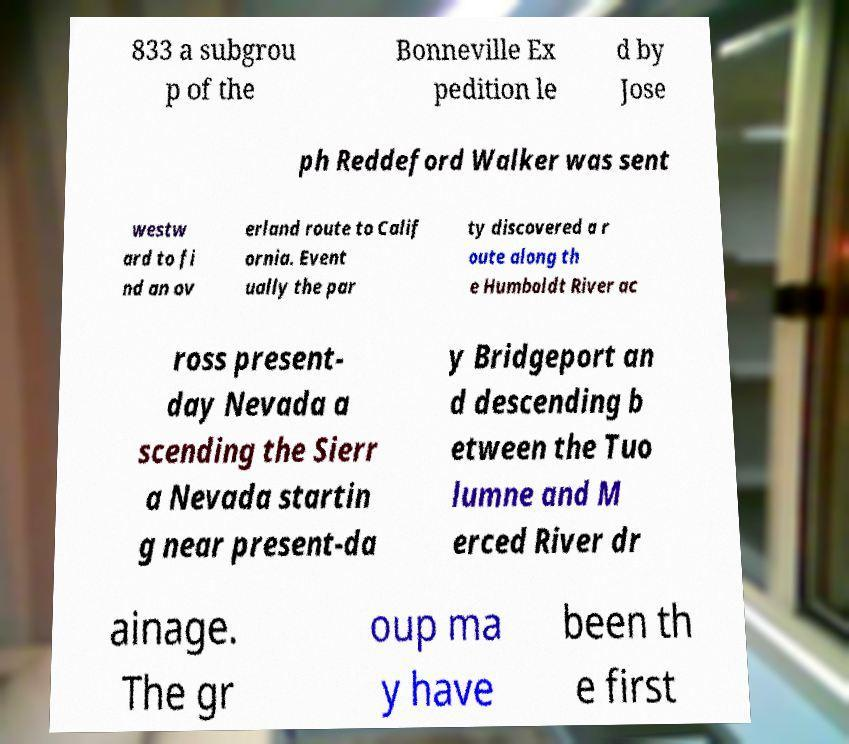Please read and relay the text visible in this image. What does it say? 833 a subgrou p of the Bonneville Ex pedition le d by Jose ph Reddeford Walker was sent westw ard to fi nd an ov erland route to Calif ornia. Event ually the par ty discovered a r oute along th e Humboldt River ac ross present- day Nevada a scending the Sierr a Nevada startin g near present-da y Bridgeport an d descending b etween the Tuo lumne and M erced River dr ainage. The gr oup ma y have been th e first 